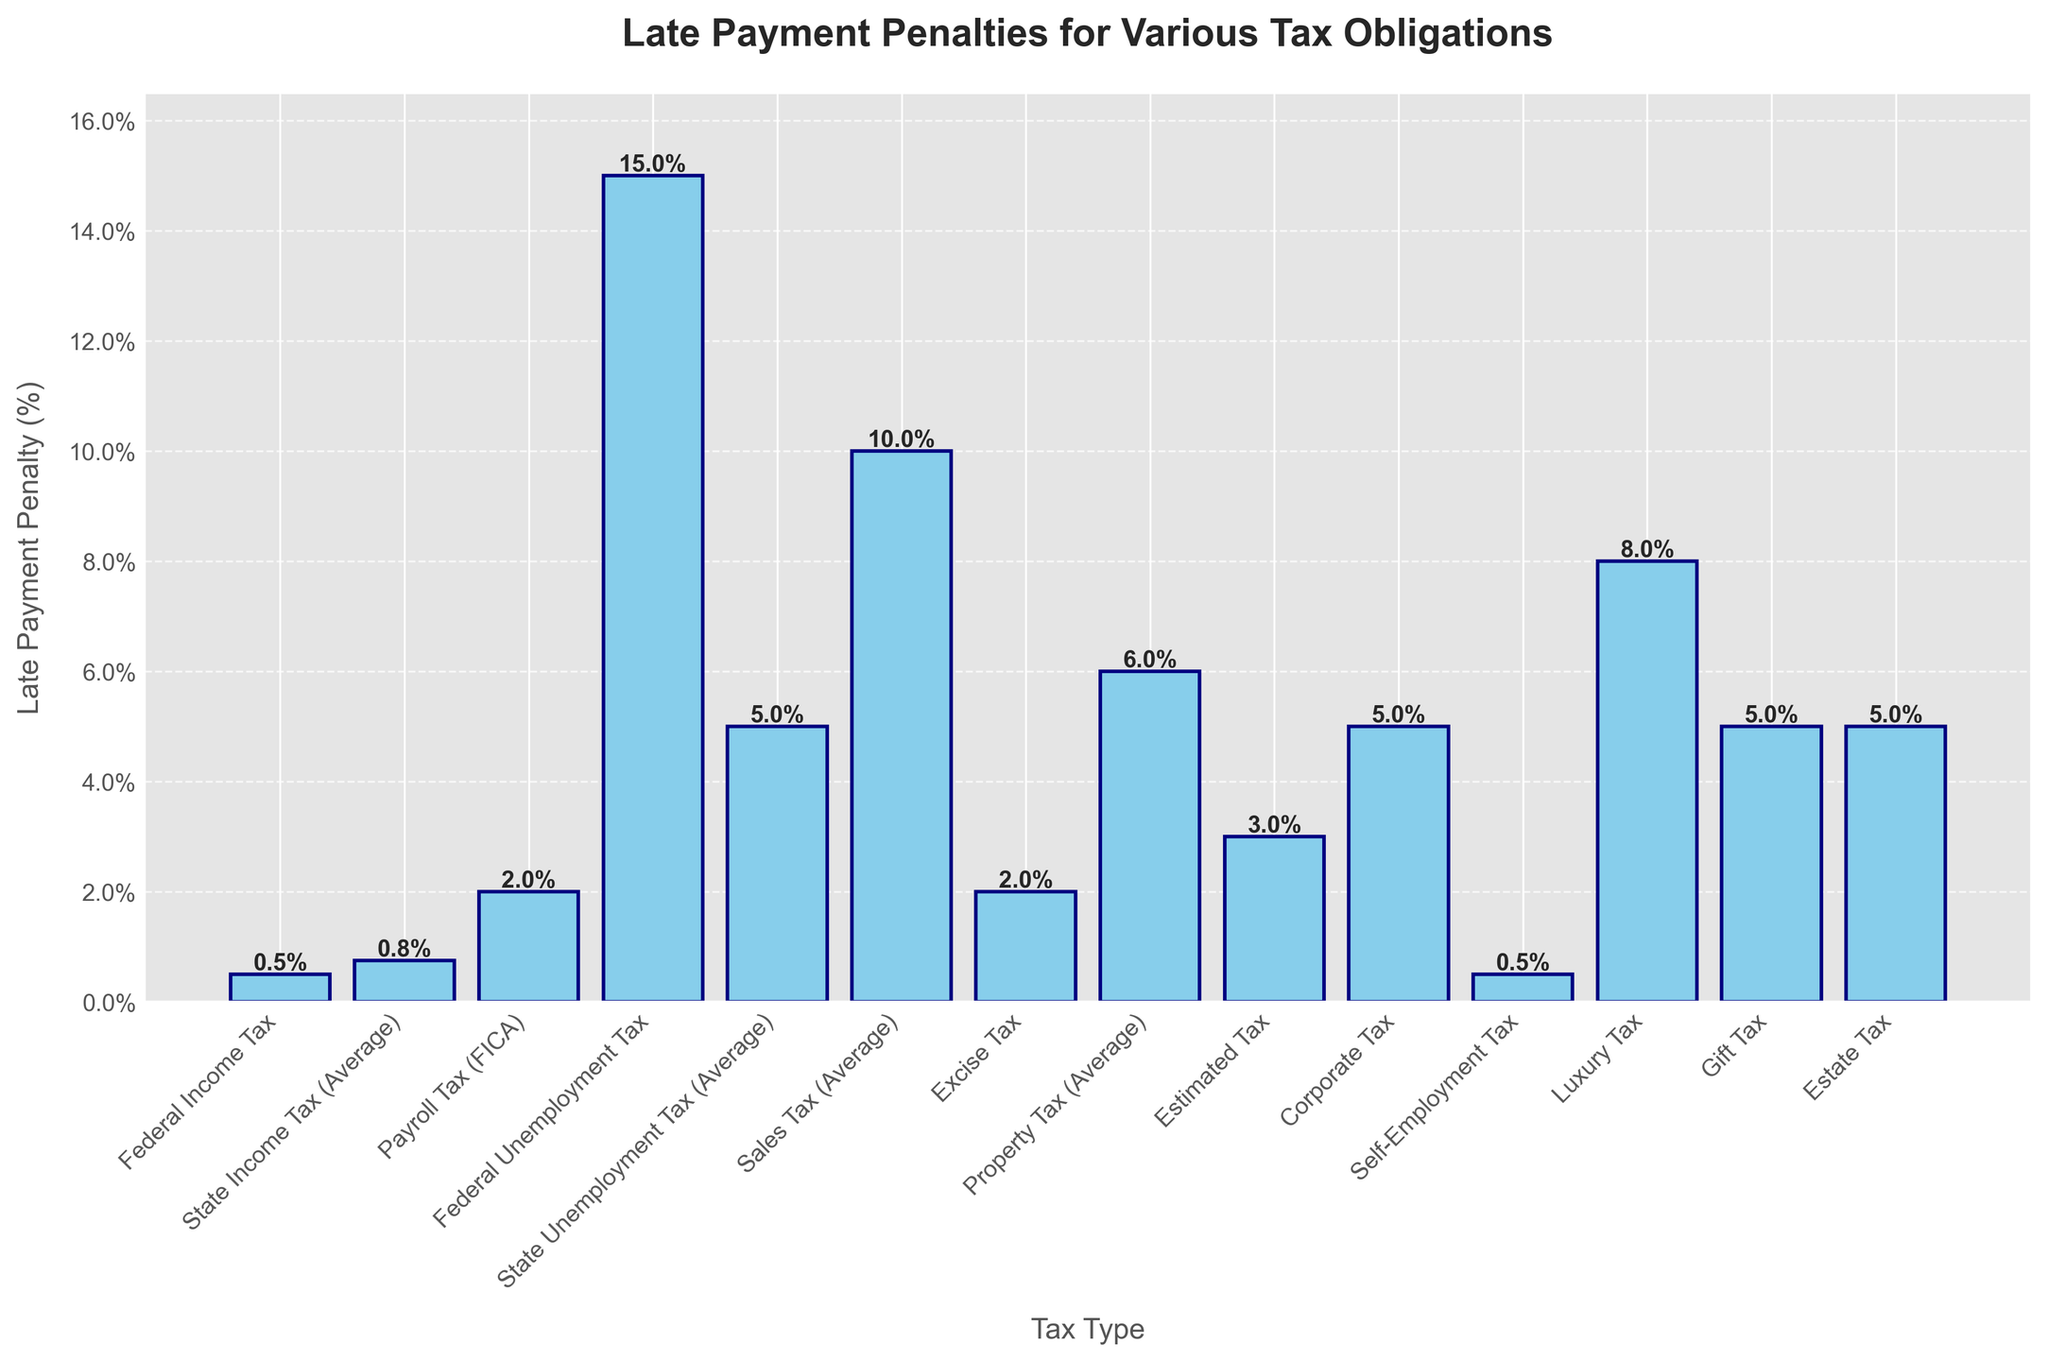Which tax has the highest late payment penalty? The bar representing the Federal Unemployment Tax reaches the highest value. By visually comparing the heights of all the bars, it is clear that the Federal Unemployment Tax penalty is the highest.
Answer: Federal Unemployment Tax Which taxes have the same late payment penalty rate? By observing the heights of the bars, you can identify that Property Tax, Corporate Tax, Gift Tax, and Estate Tax bars are of equal height, indicating the same late payment penalty.
Answer: Property Tax, Corporate Tax, Gift Tax, Estate Tax What is the difference in late payment penalty between Sales Tax and Payroll Tax (FICA)? Subtract the late payment penalty percentage of Payroll Tax (2.0%) from the late payment penalty percentage of Sales Tax (10.0%). The difference is calculated as 10.0% - 2.0%.
Answer: 8.0% What is the average late payment penalty for State Income Tax, Property Tax, and Luxury Tax? Add the penalties (0.75%, 6.0%, and 8.0%) and divide by 3 to find the average: (0.75% + 6.0% + 8.0%) / 3 = 14.75% / 3.
Answer: 4.92% Which tax has the lowest late payment penalty? By comparing the heights of all bars, the Federal Income Tax and Self-Employment Tax bars are visibly the shortest. Thus, both penalties are the lowest.
Answer: Federal Income Tax and Self-Employment Tax Which tax's penalty rate is closest to the overall average penalty rate? First, calculate the overall average penalty rate by adding all the penalties and then dividing by the number of tax types: (0.5% + 0.75% + 2.0% + 15.0% + 5.0% + 10.0% + 2.0% + 6.0% + 3.0% + 5.0% + 0.5% + 8.0% + 5.0% + 5.0%) / 14 ≈ 4.68%. Then visually compare the totals to determine which bar height is closest to this average.
Answer: Estimated Tax (3.0%) What is the total penalty if you were late on Payroll Tax (FICA), Excise Tax, and Estimated Tax? Add the penalties (2.0% + 2.0% + 3.0%): 2.0% + 2.0% + 3.0% = 7.0%.
Answer: 7.0% How much greater is the Federal Unemployment Tax penalty compared to the Gift Tax and Estate Tax penalties combined? Calculate the sum of the Gift Tax and Estate Tax penalties first: 5.0% + 5.0% = 10.0%. Then subtract this sum from the Federal Unemployment Tax penalty: 15.0% - 10.0% = 5.0%.
Answer: 5.0% What fraction of the Federal Unemployment Tax penalty is the Estimated Tax penalty? Divide the Estimated Tax penalty (3.0%) by the Federal Unemployment Tax penalty (15.0%): 3.0% / 15.0% = 0.2 or 1/5.
Answer: 1/5 